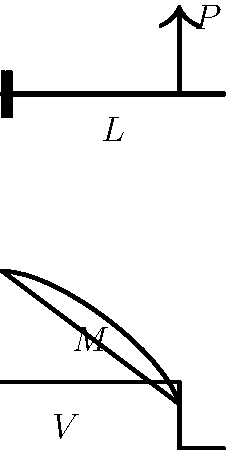In your latest TV production about engineering marvels, you're featuring a segment on cantilever beams. To ensure accuracy, you need to explain the stress distribution in a cantilever beam under a point load $P$ at its free end. If the beam has a length $L$ and a rectangular cross-section with width $b$ and height $h$, what is the maximum normal stress $\sigma_{max}$ in terms of $P$, $L$, $b$, and $h$? To find the maximum normal stress in the cantilever beam, we'll follow these steps:

1) The maximum bending moment $M_{max}$ occurs at the fixed end of the beam:
   $M_{max} = PL$

2) For a rectangular cross-section, the moment of inertia $I$ is:
   $I = \frac{1}{12}bh^3$

3) The maximum normal stress occurs at the outermost fibers of the beam, where the distance from the neutral axis $y$ is maximum:
   $y_{max} = \frac{h}{2}$

4) The formula for normal stress due to bending is:
   $\sigma = \frac{My}{I}$

5) Substituting the values we found in steps 1-3 into this formula:
   $\sigma_{max} = \frac{M_{max}y_{max}}{I} = \frac{PL \cdot \frac{h}{2}}{\frac{1}{12}bh^3}$

6) Simplify the equation:
   $\sigma_{max} = \frac{6PL}{bh^2}$

This equation gives us the maximum normal stress in the cantilever beam under the given conditions.
Answer: $\sigma_{max} = \frac{6PL}{bh^2}$ 